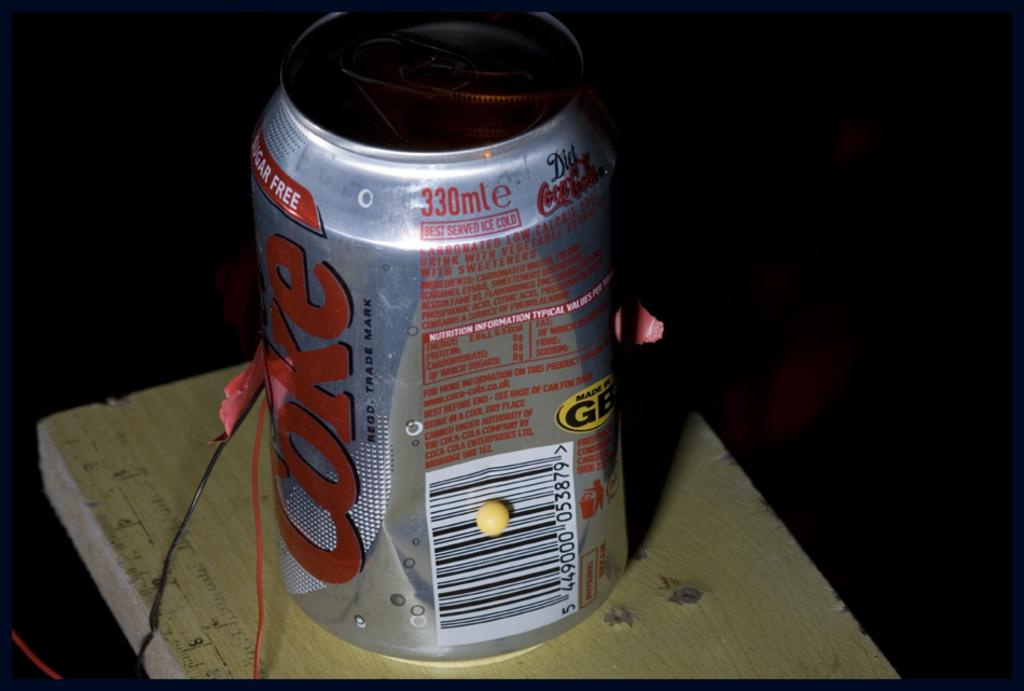<image>
Write a terse but informative summary of the picture. Can that says Coke on the side on top of a table. 